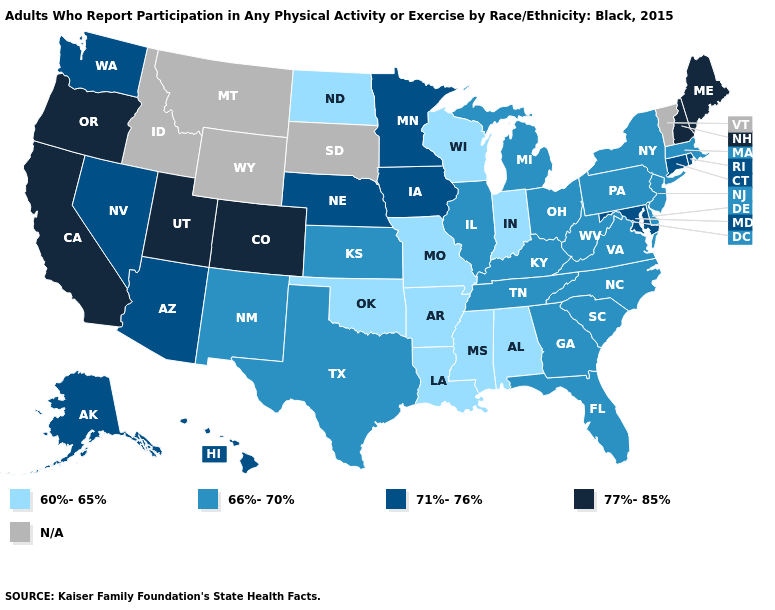Does North Dakota have the lowest value in the USA?
Concise answer only. Yes. Name the states that have a value in the range N/A?
Answer briefly. Idaho, Montana, South Dakota, Vermont, Wyoming. Which states have the highest value in the USA?
Concise answer only. California, Colorado, Maine, New Hampshire, Oregon, Utah. Does Louisiana have the lowest value in the USA?
Give a very brief answer. Yes. Among the states that border Louisiana , which have the lowest value?
Keep it brief. Arkansas, Mississippi. What is the highest value in the USA?
Keep it brief. 77%-85%. Which states have the lowest value in the USA?
Quick response, please. Alabama, Arkansas, Indiana, Louisiana, Mississippi, Missouri, North Dakota, Oklahoma, Wisconsin. What is the value of Nevada?
Give a very brief answer. 71%-76%. What is the value of South Carolina?
Give a very brief answer. 66%-70%. Among the states that border Delaware , which have the lowest value?
Keep it brief. New Jersey, Pennsylvania. Among the states that border Oklahoma , does Colorado have the highest value?
Answer briefly. Yes. Among the states that border Ohio , does West Virginia have the lowest value?
Write a very short answer. No. Which states have the highest value in the USA?
Give a very brief answer. California, Colorado, Maine, New Hampshire, Oregon, Utah. Name the states that have a value in the range 66%-70%?
Give a very brief answer. Delaware, Florida, Georgia, Illinois, Kansas, Kentucky, Massachusetts, Michigan, New Jersey, New Mexico, New York, North Carolina, Ohio, Pennsylvania, South Carolina, Tennessee, Texas, Virginia, West Virginia. What is the highest value in states that border Washington?
Keep it brief. 77%-85%. 